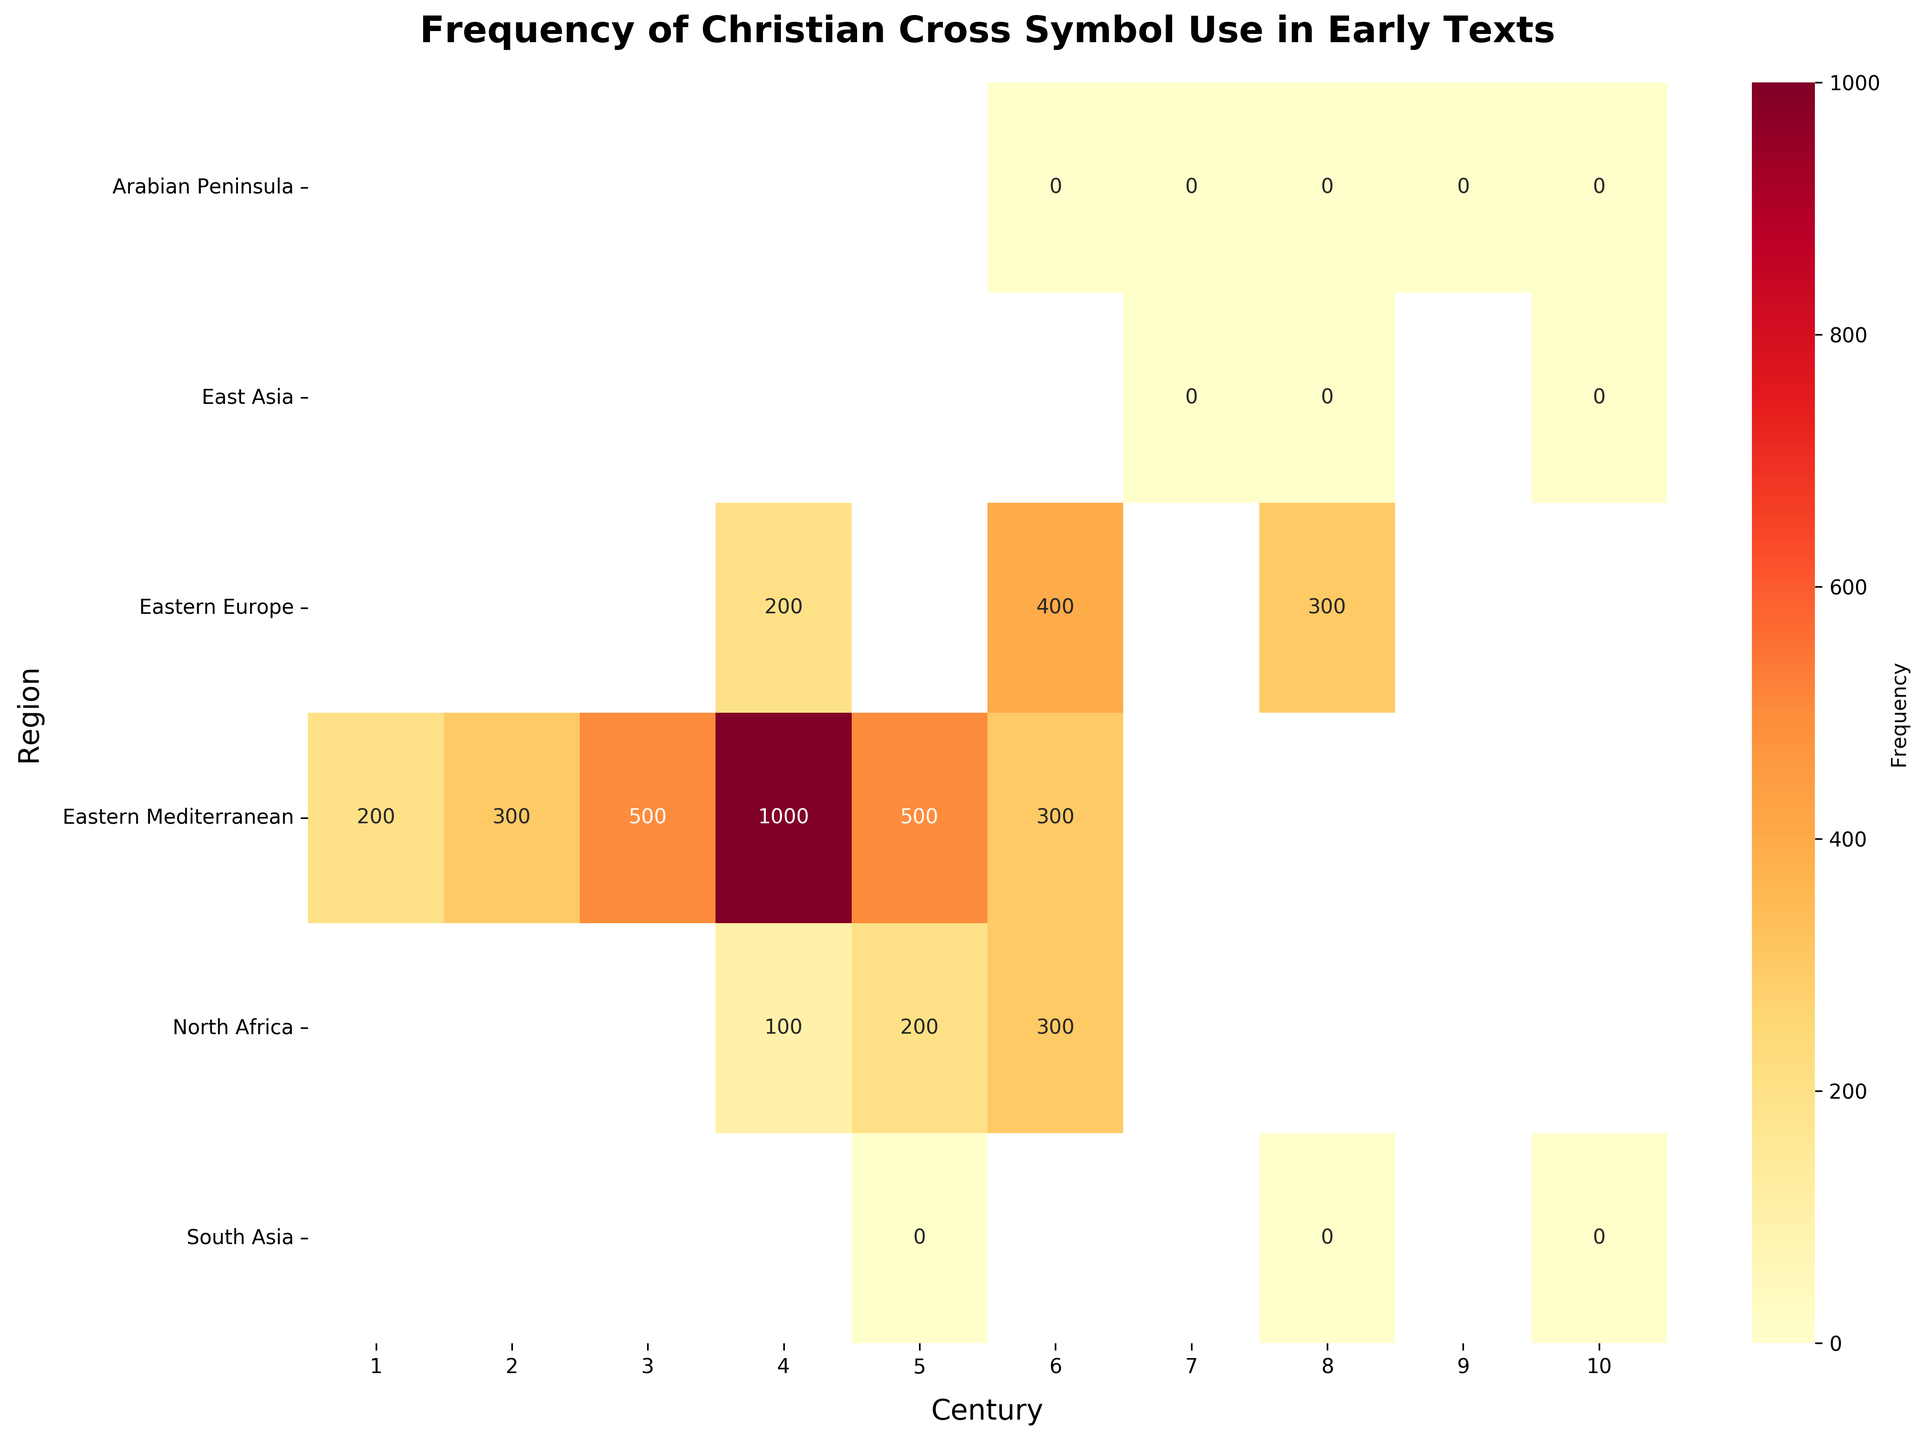What is the title of the figure? The title is usually at the top of the figure, prominently displayed.
Answer: Frequency of Christian Cross Symbol Use in Early Texts Which century had the highest frequency of Christian Cross symbol use in the Eastern Mediterranean? Locate the row corresponding to the Eastern Mediterranean region and find the column with the highest value.
Answer: 4th century In which region(s) and century(ies) were no Christian Cross symbols used? Identify regions and centuries where the heatmap displays a value of zero for the Christian Cross symbols.
Answer: Arabian Peninsula (6th-10th centuries), East Asia (7th-10th centuries), South Asia (5th-10th centuries) Compare the frequency of Christian Cross symbols in the Eastern Mediterranean in the 1st century and 6th century. Which had a higher frequency? Look at the frequencies for the 1st and 6th centuries in the Eastern Mediterranean row and compare the numbers.
Answer: 6th century How does the frequency of Christian Cross symbols in North Africa compare to that in Eastern Europe during the 4th century? Check the values for both North Africa and Eastern Europe in the 4th-century column and compare them.
Answer: North Africa: 100, Eastern Europe: 200 What is the total frequency of Christian Cross symbols in the 4th century across all regions? Sum the values for the 4th century column across all rows.
Answer: 200 + 100 + 200 + 100 = 600 Which region showed a steady increase in the frequency of Christian Cross symbol use from the 1st to the 6th century? Check each region’s values across the 1st to the 6th centuries and identify which one shows a consistent upward trend.
Answer: Eastern Mediterranean In which century did Eastern Europe first show a recorded use of the Christian Cross symbols? Look for the first non-zero value in the row corresponding to Eastern Europe.
Answer: 4th century Which region showed no use of the Christian Cross symbol throughout all recorded centuries? Identify the region(s) with a row of zeros for all centuries.
Answer: South Asia, East Asia, Arabian Peninsula 